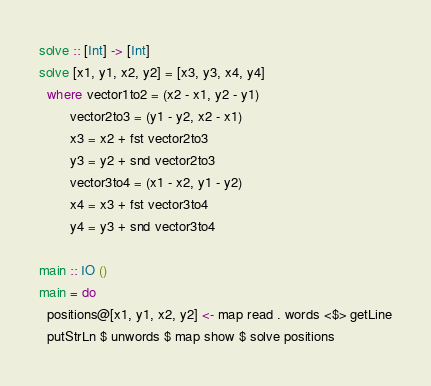<code> <loc_0><loc_0><loc_500><loc_500><_Haskell_>solve :: [Int] -> [Int]
solve [x1, y1, x2, y2] = [x3, y3, x4, y4]
  where vector1to2 = (x2 - x1, y2 - y1)
        vector2to3 = (y1 - y2, x2 - x1)
        x3 = x2 + fst vector2to3
        y3 = y2 + snd vector2to3
        vector3to4 = (x1 - x2, y1 - y2)
        x4 = x3 + fst vector3to4
        y4 = y3 + snd vector3to4

main :: IO ()
main = do
  positions@[x1, y1, x2, y2] <- map read . words <$> getLine
  putStrLn $ unwords $ map show $ solve positions</code> 